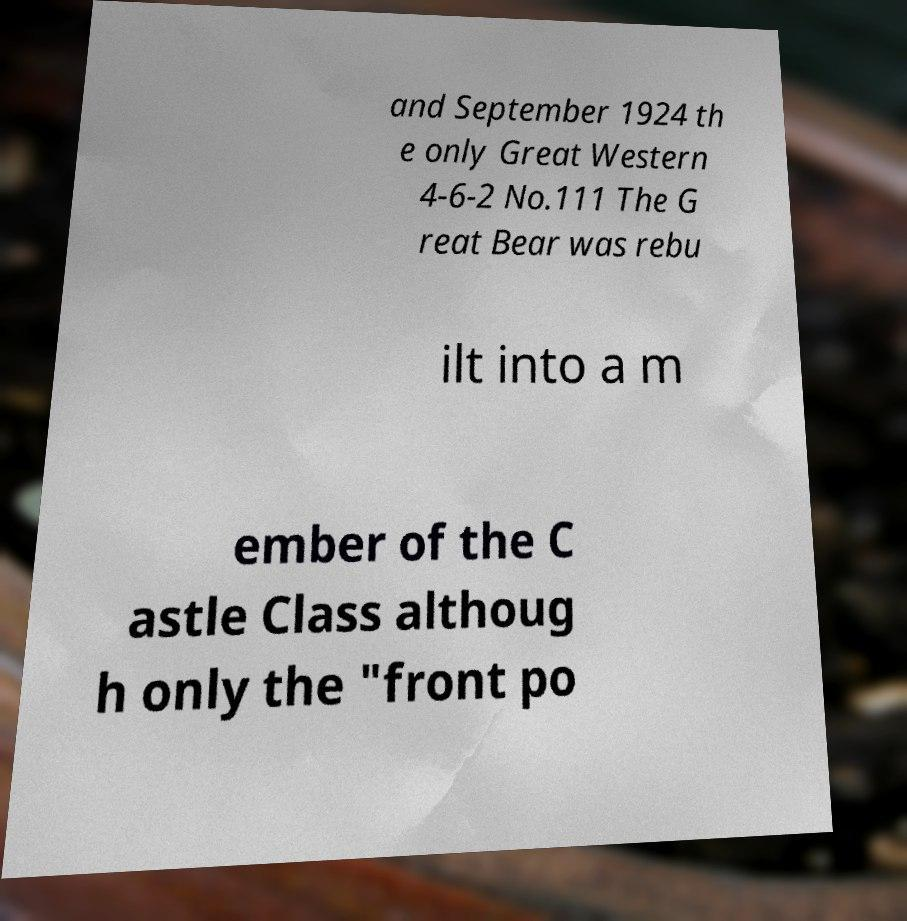For documentation purposes, I need the text within this image transcribed. Could you provide that? and September 1924 th e only Great Western 4-6-2 No.111 The G reat Bear was rebu ilt into a m ember of the C astle Class althoug h only the "front po 